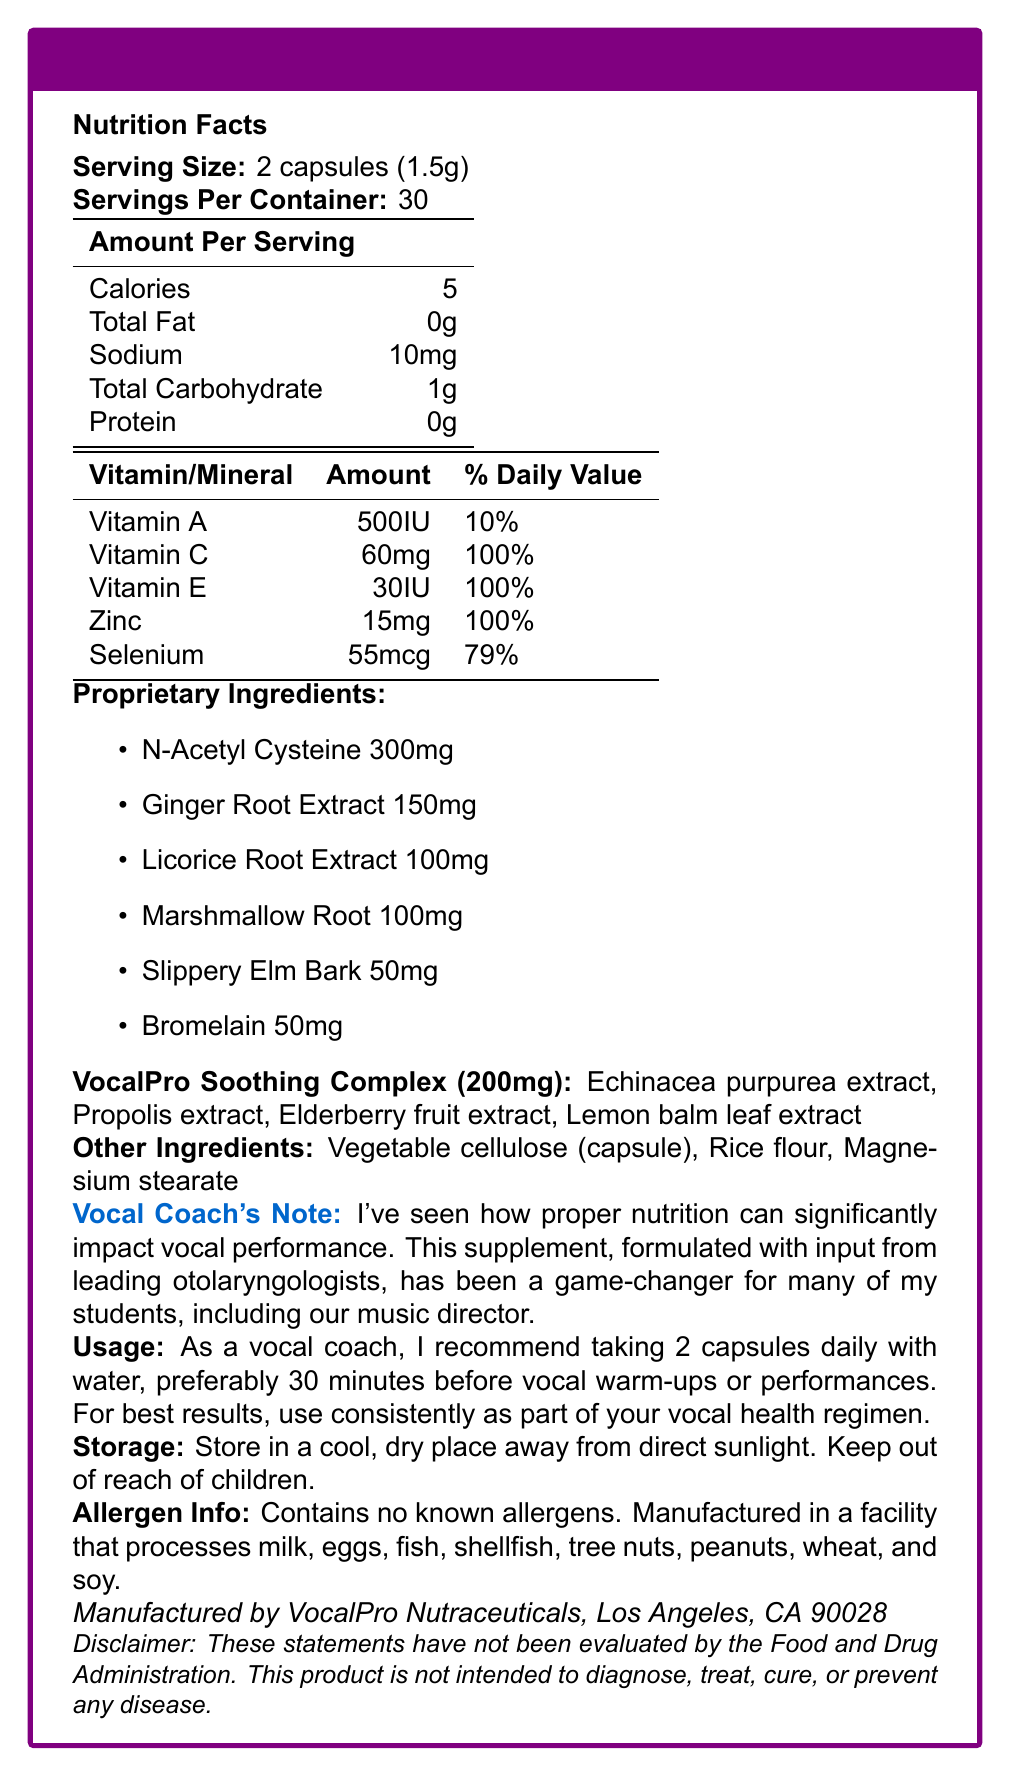what is the serving size? The serving size is listed as "2 capsules (1.5g)" under the "Nutrition Facts".
Answer: 2 capsules (1.5g) how many calories are in one serving? The document states that one serving contains 5 calories.
Answer: 5 what percentage of daily value does vitamin C provide? The document shows that Vitamin C provides 60mg per serving, equivalent to 100% of the daily value.
Answer: 100% what ingredients are in the "VocalPro Soothing Complex"? The "VocalPro Soothing Complex" is listed to contain these ingredients, with a total weight of 200mg.
Answer: Echinacea purpurea extract, Propolis extract, Elderberry fruit extract, Lemon balm leaf extract how much selenium is in each serving? The nutrition facts section indicates there are 55mcg of selenium per serving, which is 79% of the daily value.
Answer: 55mcg what is the recommended usage of this supplement? The usage instructions state to take 2 capsules daily with water, preferably 30 minutes before vocal warm-ups or performances.
Answer: 2 capsules daily with water, preferably 30 minutes before vocal warm-ups or performances where should this product be stored? The storage information advises keeping the product in a cool, dry place away from direct sunlight and out of reach of children.
Answer: In a cool, dry place away from direct sunlight. Keep out of reach of children. what are the main allergens this product is free from? A. Wheat B. Eggs C. Tree nuts D. None of the above The document states that there are no known allergens, although it is manufactured in a facility that processes many common allergens such as milk, eggs, fish, shellfish, tree nuts, peanuts, wheat, and soy.
Answer: D. None of the above which of the following is NOT an ingredient in the capsules? I. Bromelain II. Rice flour III. Potassium IV. Slippery Elm Bark Potassium is not listed as one of the ingredients in the capsules, while Bromelain, Rice flour, and Slippery Elm Bark are mentioned.
Answer: III. Potassium is this supplement intended to diagnose or cure any disease? The disclaimer explicitly states that this product is not intended to diagnose, treat, cure, or prevent any disease.
Answer: No summarize the main purpose and components of this supplement. The document provides comprehensive information about the supplement's purpose, ingredients, usage instructions, storage guidelines, and allergen information, suggesting that it aims to improve vocal health through a combination of vitamins, minerals, and natural extracts.
Answer: The VocalPro Harmony Boost is a supplement designed to support vocal health for professional singers. It contains vitamins (A, C, E), minerals (Zinc, Selenium), various herbal extracts, and a proprietary blend called VocalPro Soothing Complex. The recommended usage is to take 2 capsules daily for optimal vocal performance. what is the primary benefit of including Bromelain in the supplement? The document does not detail the specific benefits of Bromelain, only listing it as an ingredient.
Answer: Not enough information 